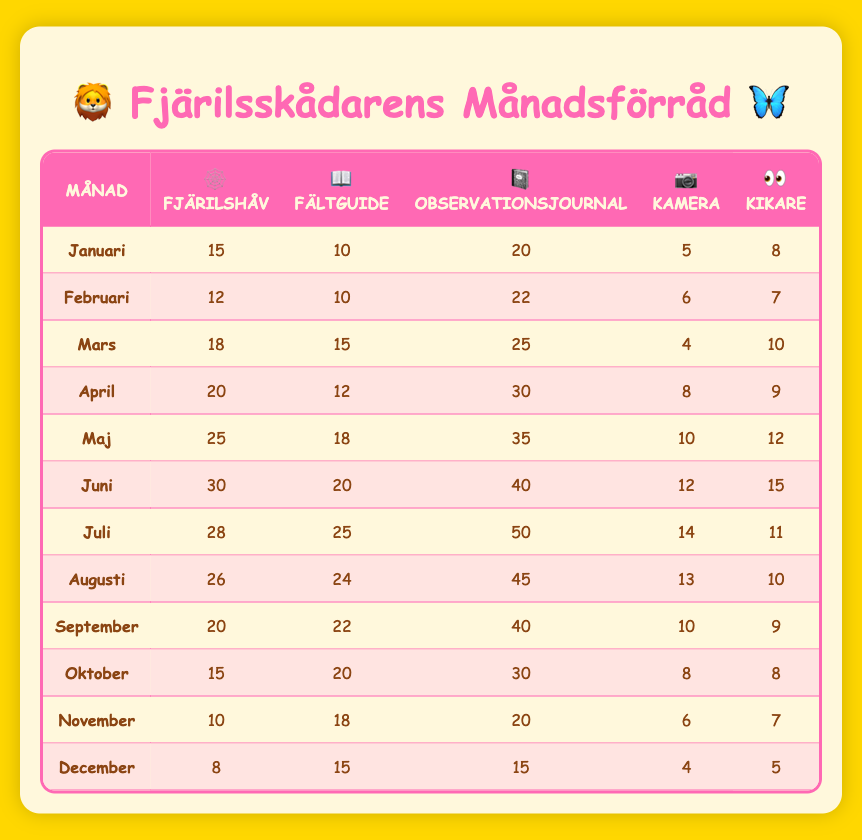what is the total number of butterfly nets available in June? In June, the table shows that there are 30 butterfly nets. Therefore, the total number of butterfly nets available in June is simply the value listed in that row.
Answer: 30 how many observation journals were available in May? The table indicates that in May, there were 35 observation journals. This information is taken directly from the specific row for May.
Answer: 35 which month had the highest number of cameras? By examining the camera column for each month, June stands out with 12 cameras being recorded. Thus, June has the maximum quantity of cameras when compared to other months.
Answer: June did the number of binoculars available increase or decrease from April to November? In April, there were 9 binoculars, and in November, there were 7. Since the number of binoculars decreased from 9 to 7, the answer is that it decreased.
Answer: Decreased what is the average number of field guides available from January to March? To find the average, we first total the number of field guides for January (10), February (10), and March (15), which gives us a sum of 35. Then, we divide this total by the number of months, which is 3. Therefore, the average number is 35 divided by 3, resulting in approximately 11.67.
Answer: 11.67 how many more observation journals were there in July compared to January? In July, there were 50 observation journals, while in January, there were 20. To find the difference, we subtract the number of journals in January from those in July: 50 minus 20 equals 30. This shows that there were 30 more journals in July than in January.
Answer: 30 which month had the least number of binoculars? Looking through the binoculars column, we find December with only 5 binoculars. This is the smallest number when compared to all other months listed.
Answer: December what was the total number of butterfly nets from April to June? To calculate this, we sum the number of butterfly nets for April (20), May (25), and June (30), which results in a total of 75. This is the final tally of butterfly nets across these three months combined.
Answer: 75 is it true that the number of cameras was higher in August compared to April? The number of cameras recorded in August was 13, while in April it was 8. Since 13 is greater than 8, the statement is confirmed to be true.
Answer: True 